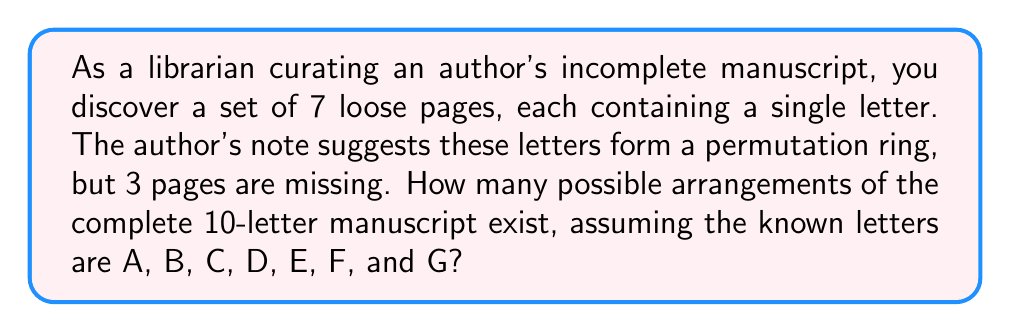Provide a solution to this math problem. To solve this problem, we need to use concepts from permutation rings and combinatorics. Let's break it down step-by-step:

1) First, we need to understand what a permutation ring is. In ring theory, a permutation ring is a cyclic arrangement of elements where the order matters, but the starting point doesn't.

2) We have 7 known letters (A, B, C, D, E, F, G) and 3 unknown letters, making a total of 10 letters.

3) To find the total number of arrangements, we need to:
   a) Calculate the number of ways to arrange 10 letters in a ring
   b) Multiply this by the number of ways to choose positions for the 3 unknown letters

4) The number of distinct arrangements in a permutation ring of n elements is $(n-1)!$
   In this case, $n = 10$, so we have $(10-1)! = 9! = 362,880$

5) Now, we need to calculate the number of ways to choose 3 positions out of 10 for the unknown letters. This is a combination problem, denoted as $\binom{10}{3}$

6) $\binom{10}{3} = \frac{10!}{3!(10-3)!} = \frac{10!}{3!7!} = 120$

7) The total number of possible arrangements is the product of these two values:

   $$ 9! \times \binom{10}{3} = 362,880 \times 120 = 43,545,600 $$

Therefore, there are 43,545,600 possible arrangements of the complete 10-letter manuscript.
Answer: 43,545,600 possible arrangements 